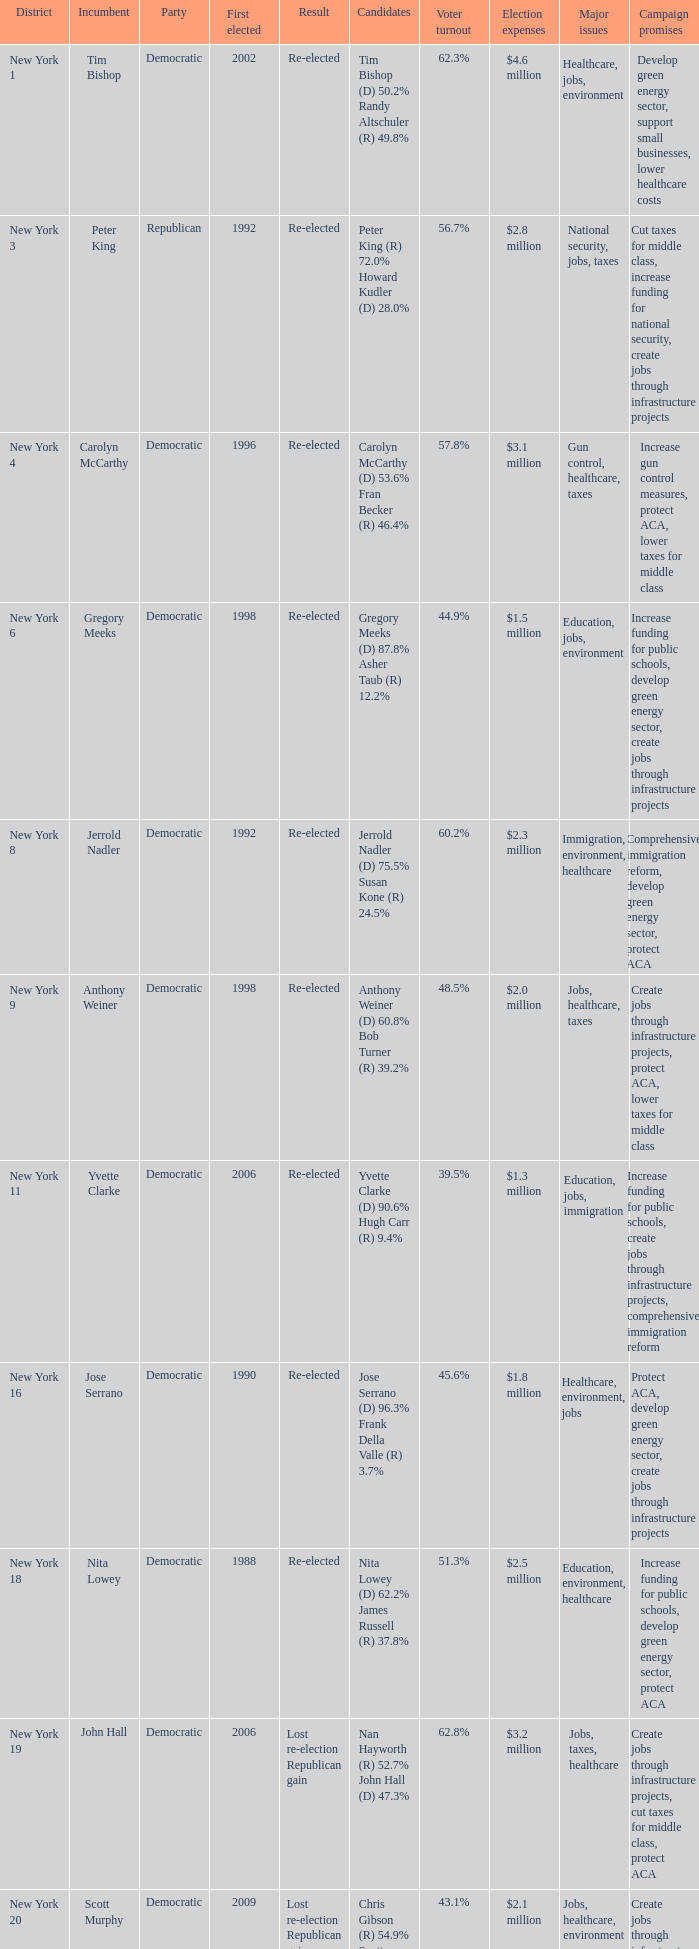Name the result for new york 8 Re-elected. 